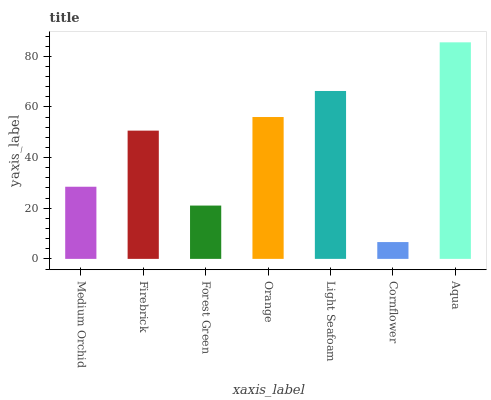Is Cornflower the minimum?
Answer yes or no. Yes. Is Aqua the maximum?
Answer yes or no. Yes. Is Firebrick the minimum?
Answer yes or no. No. Is Firebrick the maximum?
Answer yes or no. No. Is Firebrick greater than Medium Orchid?
Answer yes or no. Yes. Is Medium Orchid less than Firebrick?
Answer yes or no. Yes. Is Medium Orchid greater than Firebrick?
Answer yes or no. No. Is Firebrick less than Medium Orchid?
Answer yes or no. No. Is Firebrick the high median?
Answer yes or no. Yes. Is Firebrick the low median?
Answer yes or no. Yes. Is Light Seafoam the high median?
Answer yes or no. No. Is Aqua the low median?
Answer yes or no. No. 